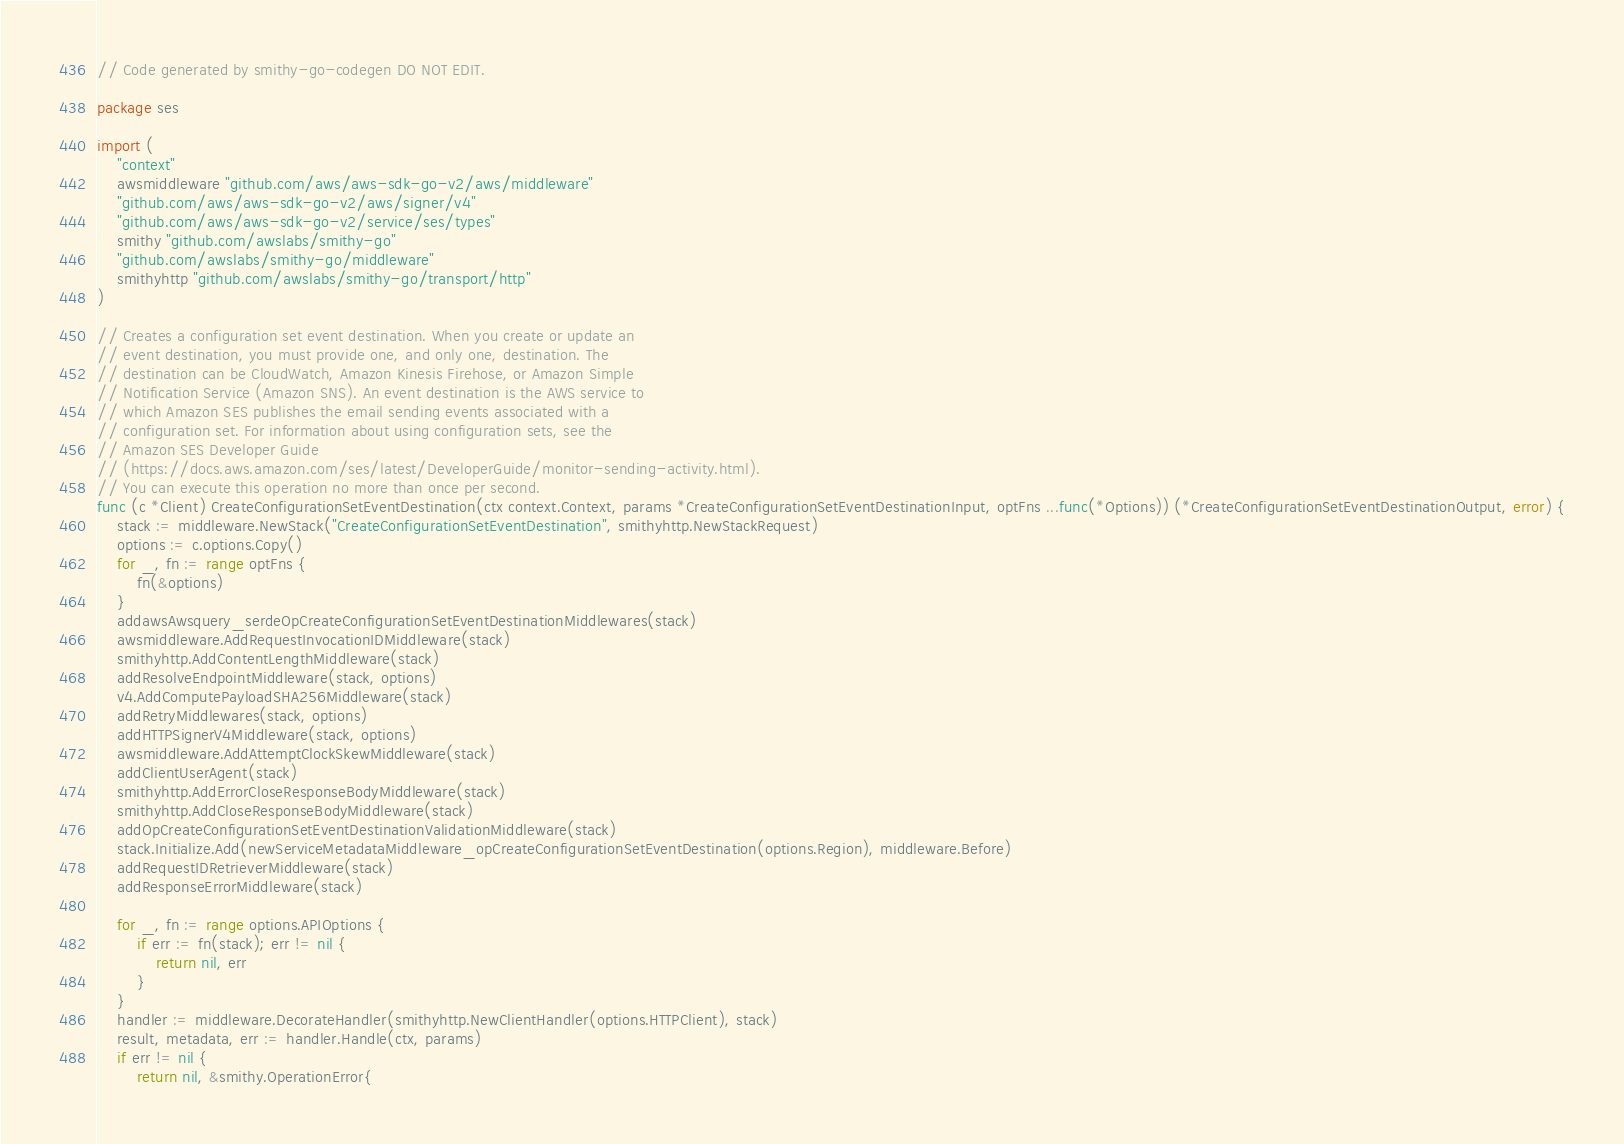Convert code to text. <code><loc_0><loc_0><loc_500><loc_500><_Go_>// Code generated by smithy-go-codegen DO NOT EDIT.

package ses

import (
	"context"
	awsmiddleware "github.com/aws/aws-sdk-go-v2/aws/middleware"
	"github.com/aws/aws-sdk-go-v2/aws/signer/v4"
	"github.com/aws/aws-sdk-go-v2/service/ses/types"
	smithy "github.com/awslabs/smithy-go"
	"github.com/awslabs/smithy-go/middleware"
	smithyhttp "github.com/awslabs/smithy-go/transport/http"
)

// Creates a configuration set event destination. When you create or update an
// event destination, you must provide one, and only one, destination. The
// destination can be CloudWatch, Amazon Kinesis Firehose, or Amazon Simple
// Notification Service (Amazon SNS). An event destination is the AWS service to
// which Amazon SES publishes the email sending events associated with a
// configuration set. For information about using configuration sets, see the
// Amazon SES Developer Guide
// (https://docs.aws.amazon.com/ses/latest/DeveloperGuide/monitor-sending-activity.html).
// You can execute this operation no more than once per second.
func (c *Client) CreateConfigurationSetEventDestination(ctx context.Context, params *CreateConfigurationSetEventDestinationInput, optFns ...func(*Options)) (*CreateConfigurationSetEventDestinationOutput, error) {
	stack := middleware.NewStack("CreateConfigurationSetEventDestination", smithyhttp.NewStackRequest)
	options := c.options.Copy()
	for _, fn := range optFns {
		fn(&options)
	}
	addawsAwsquery_serdeOpCreateConfigurationSetEventDestinationMiddlewares(stack)
	awsmiddleware.AddRequestInvocationIDMiddleware(stack)
	smithyhttp.AddContentLengthMiddleware(stack)
	addResolveEndpointMiddleware(stack, options)
	v4.AddComputePayloadSHA256Middleware(stack)
	addRetryMiddlewares(stack, options)
	addHTTPSignerV4Middleware(stack, options)
	awsmiddleware.AddAttemptClockSkewMiddleware(stack)
	addClientUserAgent(stack)
	smithyhttp.AddErrorCloseResponseBodyMiddleware(stack)
	smithyhttp.AddCloseResponseBodyMiddleware(stack)
	addOpCreateConfigurationSetEventDestinationValidationMiddleware(stack)
	stack.Initialize.Add(newServiceMetadataMiddleware_opCreateConfigurationSetEventDestination(options.Region), middleware.Before)
	addRequestIDRetrieverMiddleware(stack)
	addResponseErrorMiddleware(stack)

	for _, fn := range options.APIOptions {
		if err := fn(stack); err != nil {
			return nil, err
		}
	}
	handler := middleware.DecorateHandler(smithyhttp.NewClientHandler(options.HTTPClient), stack)
	result, metadata, err := handler.Handle(ctx, params)
	if err != nil {
		return nil, &smithy.OperationError{</code> 